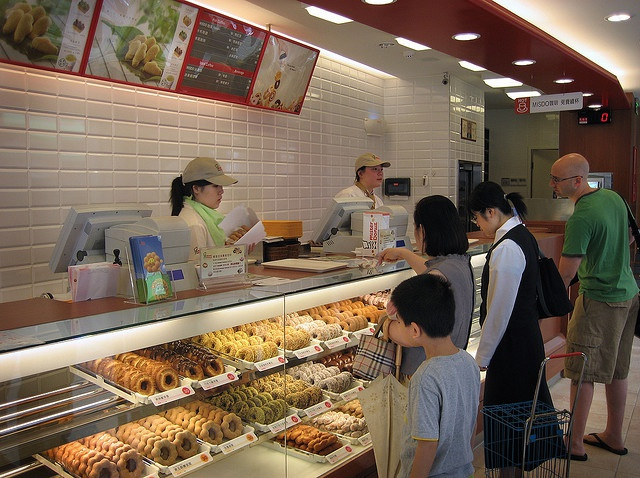Describe the objects in this image and their specific colors. I can see people in darkgreen, black, darkgray, and gray tones, people in darkgreen, black, maroon, and gray tones, people in darkgreen, gray, black, and maroon tones, people in darkgreen, black, gray, and brown tones, and people in darkgreen, tan, gray, and black tones in this image. 